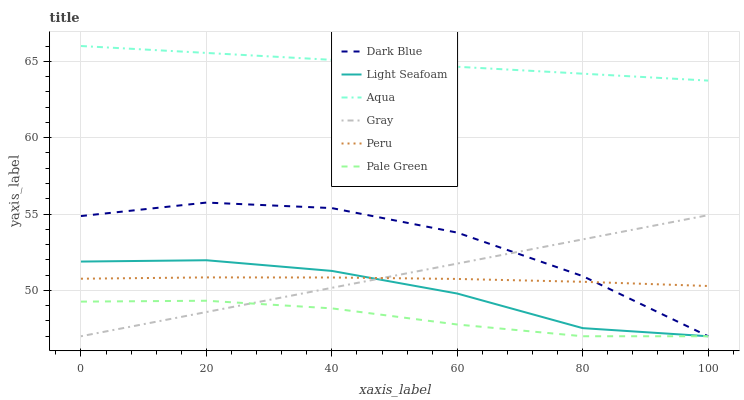Does Pale Green have the minimum area under the curve?
Answer yes or no. Yes. Does Aqua have the maximum area under the curve?
Answer yes or no. Yes. Does Dark Blue have the minimum area under the curve?
Answer yes or no. No. Does Dark Blue have the maximum area under the curve?
Answer yes or no. No. Is Gray the smoothest?
Answer yes or no. Yes. Is Dark Blue the roughest?
Answer yes or no. Yes. Is Aqua the smoothest?
Answer yes or no. No. Is Aqua the roughest?
Answer yes or no. No. Does Aqua have the lowest value?
Answer yes or no. No. Does Aqua have the highest value?
Answer yes or no. Yes. Does Dark Blue have the highest value?
Answer yes or no. No. Is Gray less than Aqua?
Answer yes or no. Yes. Is Peru greater than Pale Green?
Answer yes or no. Yes. Does Gray intersect Aqua?
Answer yes or no. No. 